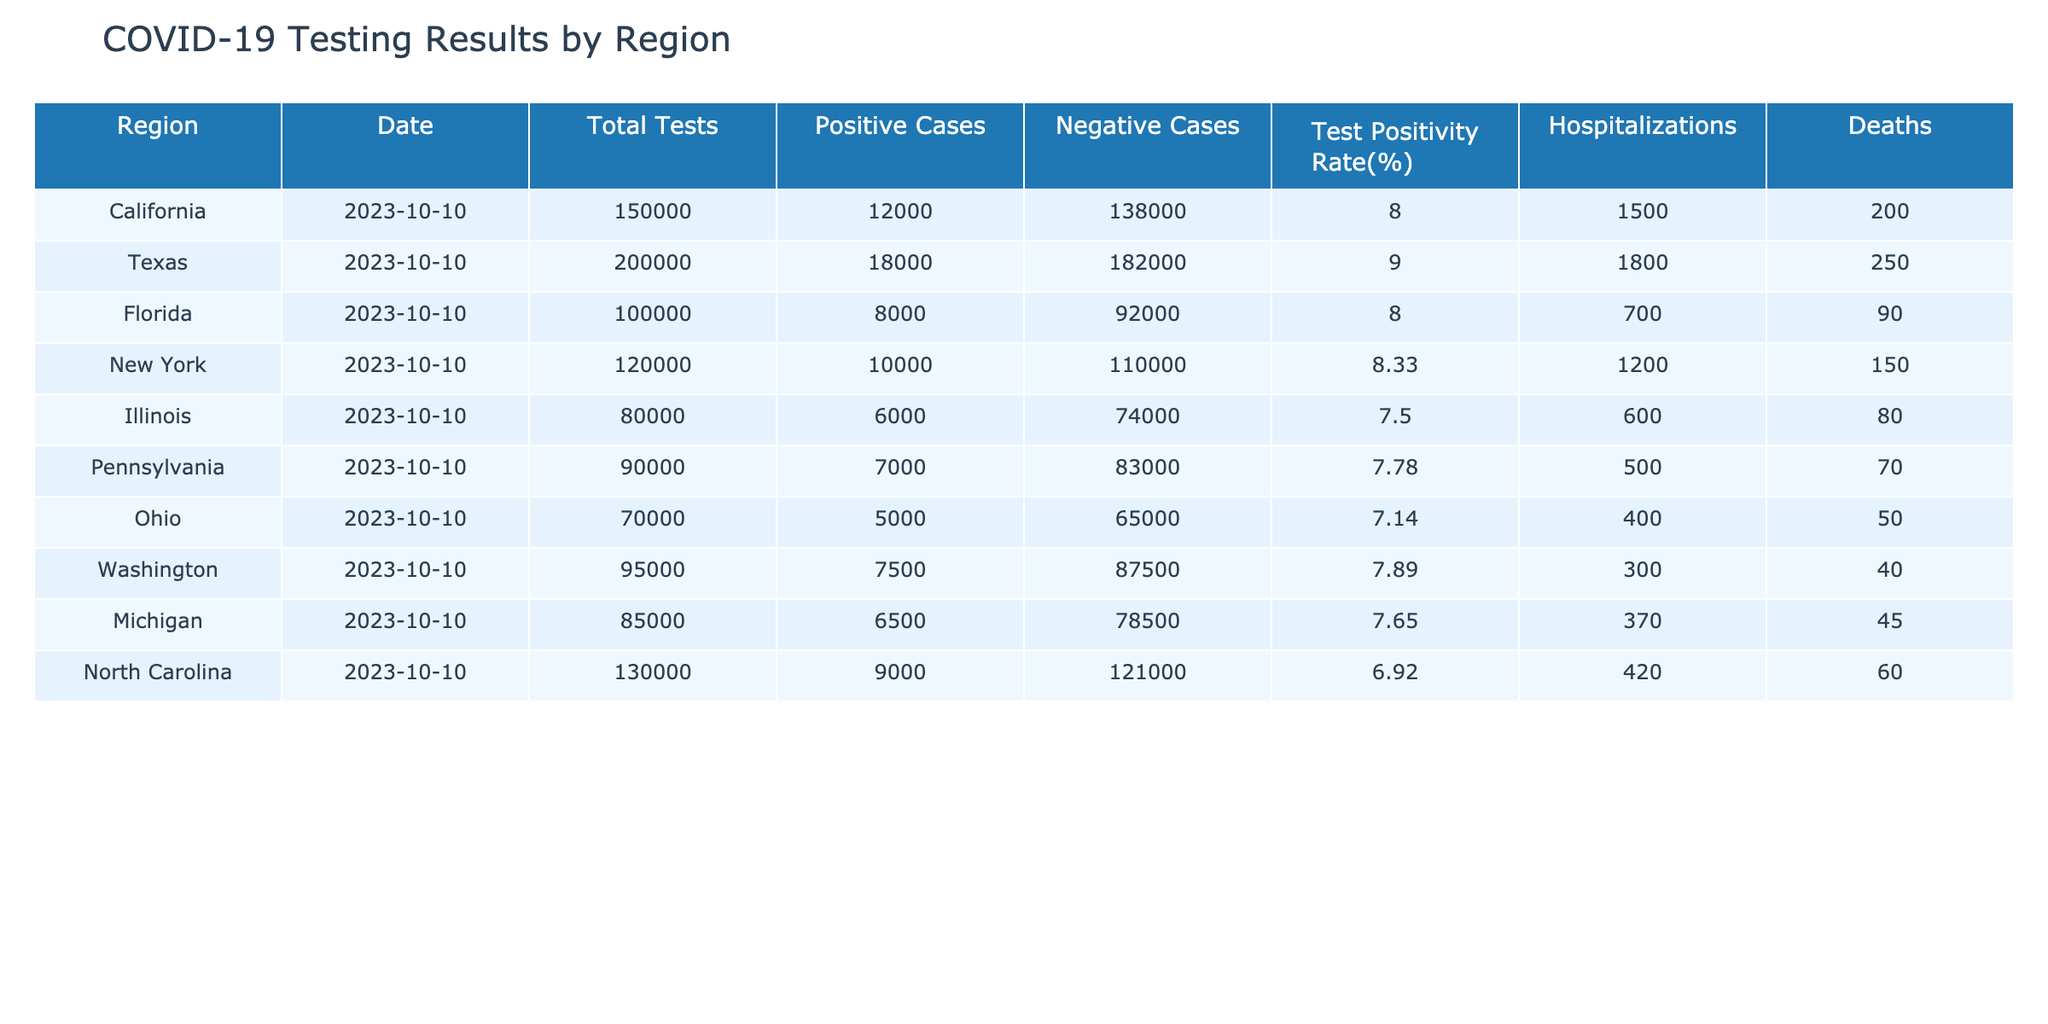What is the test positivity rate in Texas? The test positivity rate is indicated in the table under the "Test Positivity Rate(%)" column for Texas, which shows a value of 9.00.
Answer: 9.00 Which region has the highest number of positive cases recorded? By examining the "Positive Cases" column, Texas has the highest number of positive cases with a total of 18,000.
Answer: Texas How many total tests were conducted in California and Florida combined? To find the combined total, add the values in the "Total Tests" column for California (150,000) and Florida (100,000): 150,000 + 100,000 = 250,000.
Answer: 250,000 Are there any regions that recorded more than 1,000 deaths? Reviewing the "Deaths" column, Texas shows 250 deaths, California 200, and the others show fewer than 200. Thus, there are no regions with more than 1,000 deaths.
Answer: No What is the average test positivity rate across all listed regions? To calculate the average, sum all percentages from the "Test Positivity Rate(%)" column (8.00 + 9.00 + 8.00 + 8.33 + 7.50 + 7.78 + 7.14 + 7.89 + 7.65 + 6.92) = 78.21, and divide by the number of regions (10): 78.21 / 10 = 7.821.
Answer: 7.82 Which region has the lowest hospitalization figure? The "Hospitalizations" column shows Ohio with the lowest figure at 400 hospitals reported.
Answer: Ohio How many negative cases were reported in New York? The table lists the negative cases for New York in the "Negative Cases" column, which is 110,000.
Answer: 110,000 Is the test positivity rate in North Carolina less than that in Florida? North Carolina has a test positivity rate of 6.92 and Florida has 8.00. Therefore, 6.92 is indeed less than 8.00.
Answer: Yes What is the difference in total tests conducted between Pennsylvania and Illinois? To find the difference, subtract Illinois's total tests (80,000) from Pennsylvania's total tests (90,000): 90,000 - 80,000 = 10,000.
Answer: 10,000 